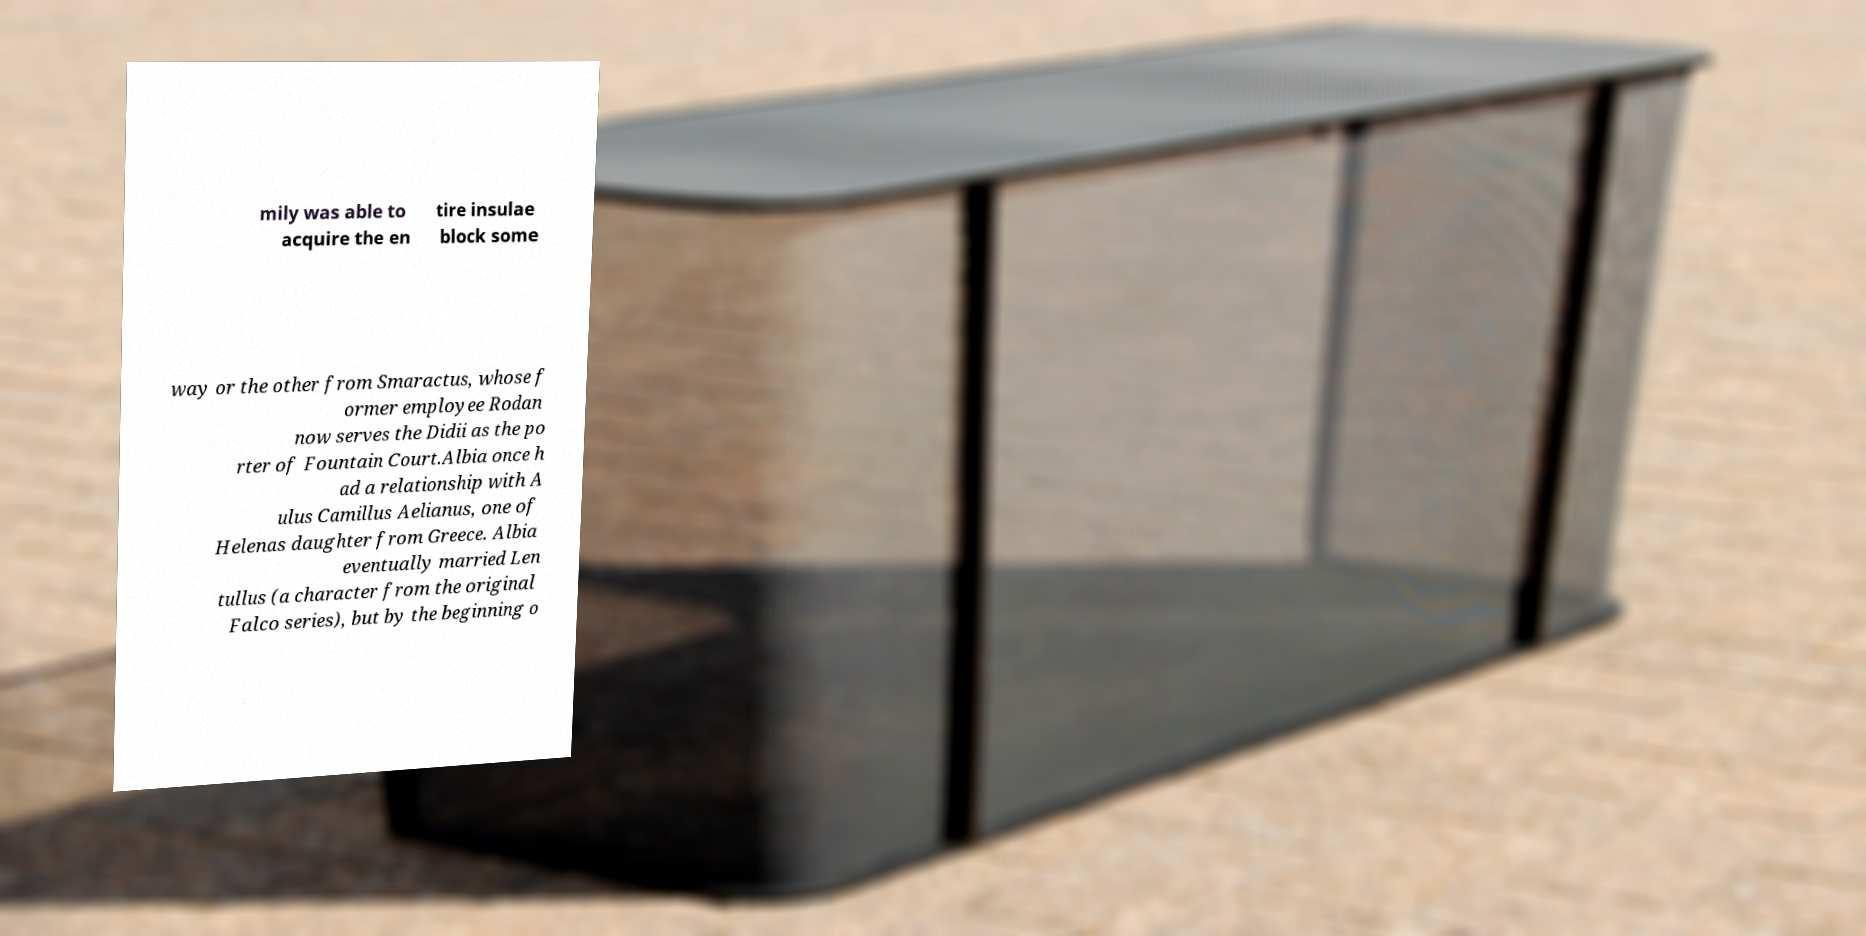Could you assist in decoding the text presented in this image and type it out clearly? mily was able to acquire the en tire insulae block some way or the other from Smaractus, whose f ormer employee Rodan now serves the Didii as the po rter of Fountain Court.Albia once h ad a relationship with A ulus Camillus Aelianus, one of Helenas daughter from Greece. Albia eventually married Len tullus (a character from the original Falco series), but by the beginning o 